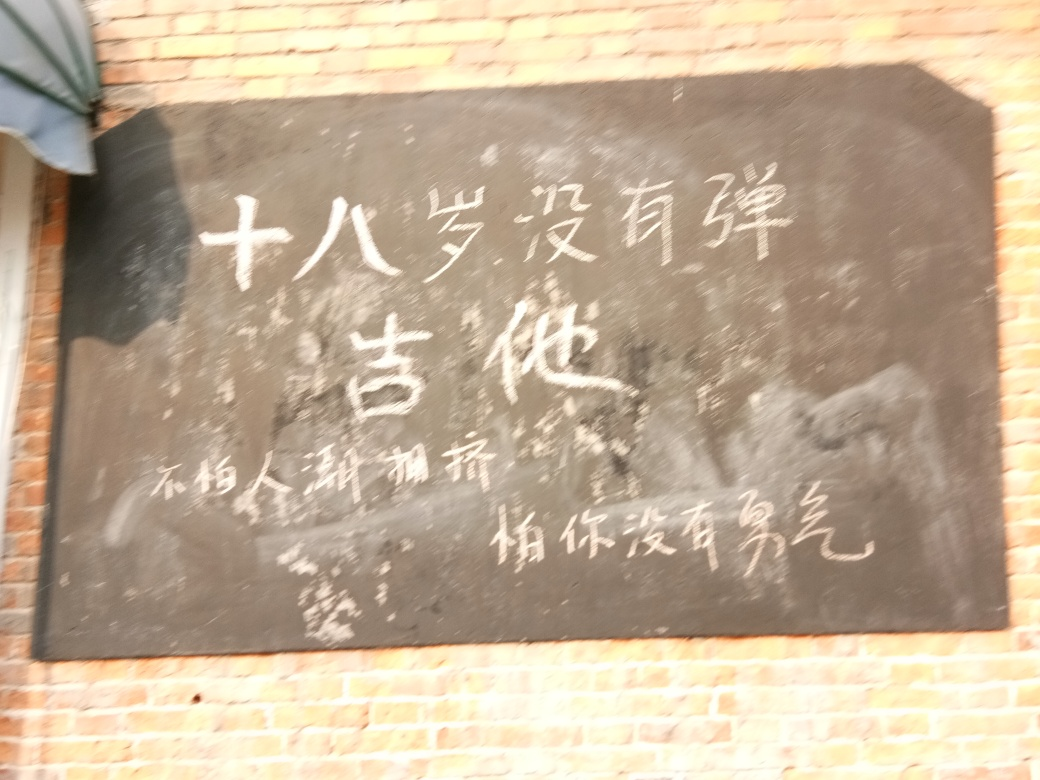Can you describe what's in the image? The image features a blackboard with handwritten chalk text. Due to the blurriness and glare, it's challenging to decipher the text. The content of the writing and its context remain uncertain without a clearer picture. 